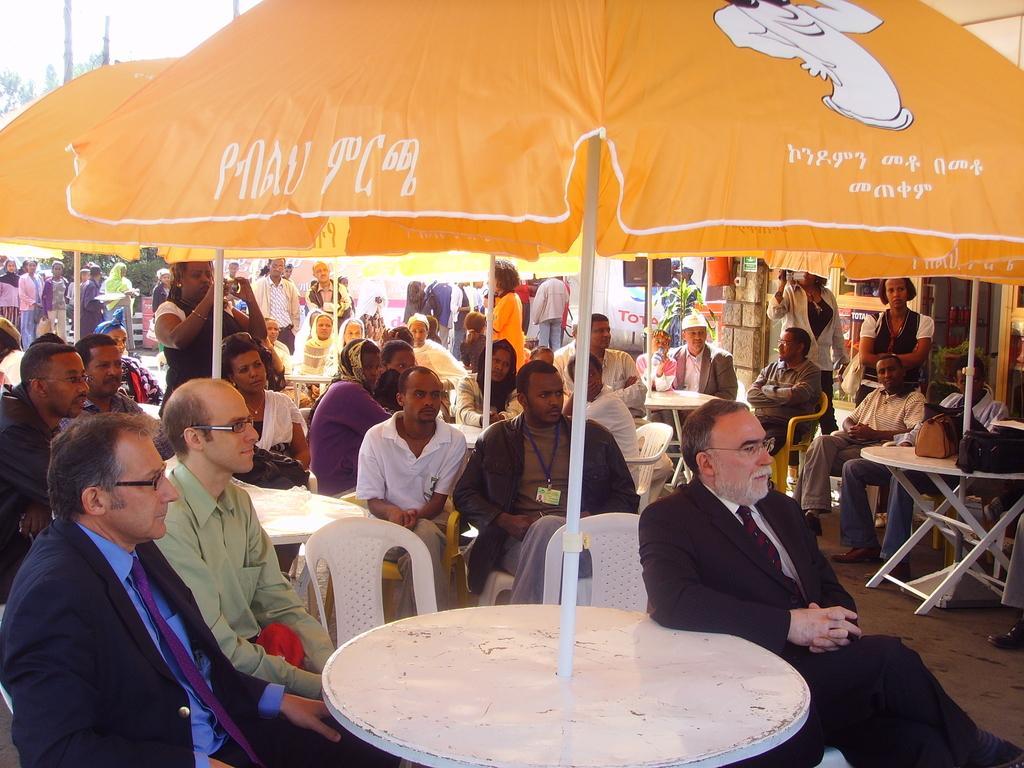How would you summarize this image in a sentence or two? There are group of persons sitting over here under the yellow color umbrella 